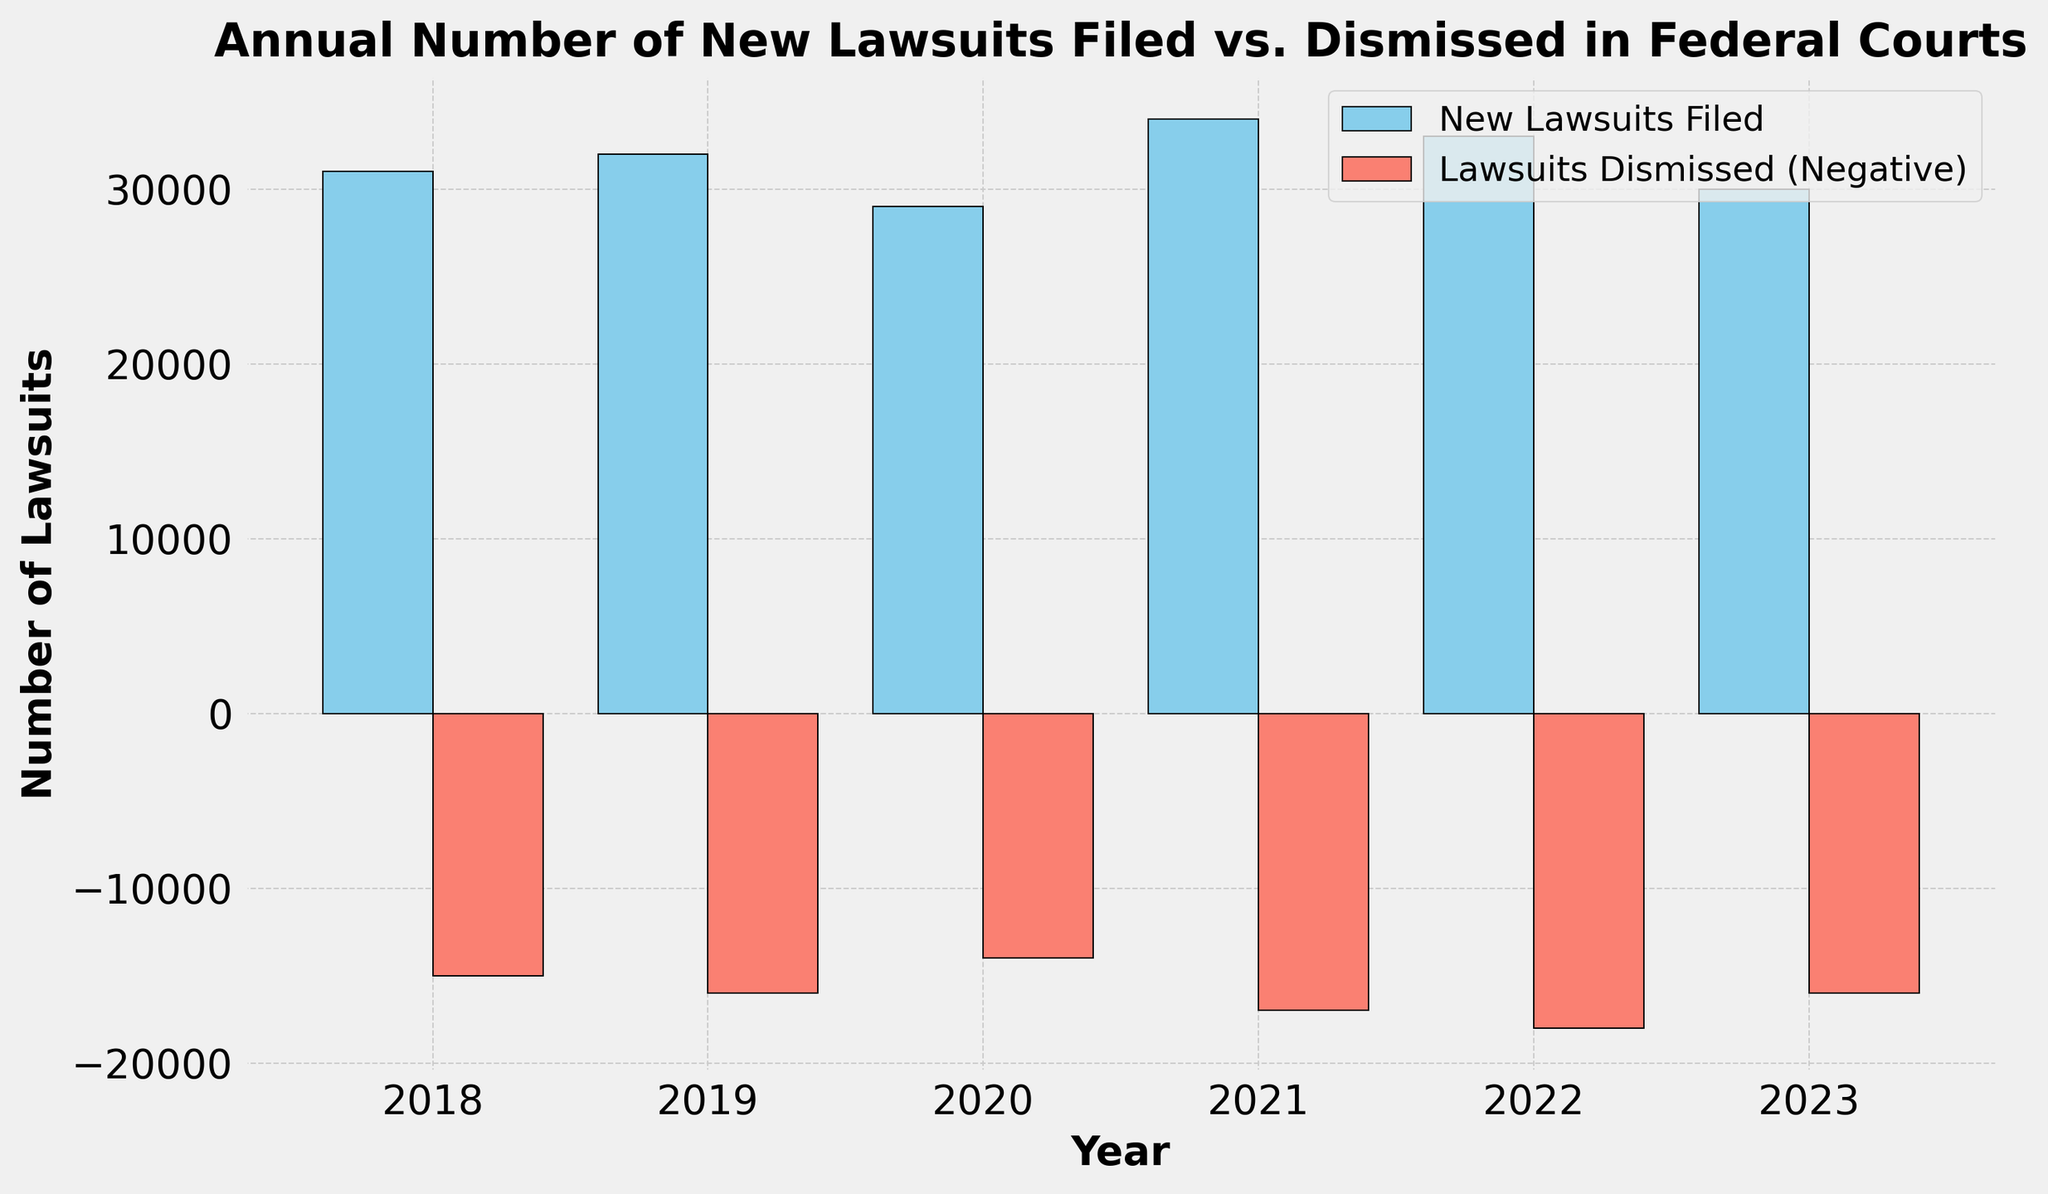What is the total number of new lawsuits filed in 2019 and 2020? To find the total number of new lawsuits filed in 2019 and 2020, add the number of new lawsuits in these years: 32,000 (2019) + 29,000 (2020) = 61,000
Answer: 61,000 How many more lawsuits were dismissed in 2022 compared to 2020? To find how many more lawsuits were dismissed in 2022 compared to 2020, subtract the number of lawsuits dismissed in 2020 from the number dismissed in 2022: 18,000 (2022) - 14,000 (2020) = 4,000
Answer: 4,000 What year had the highest number of new lawsuits filed? From the visual plot, the year with the tallest blue bar, representing new lawsuits filed, is 2021 with 34,000 lawsuits.
Answer: 2021 Compare the number of new lawsuits filed and lawsuits dismissed in 2018. Are more lawsuits filed or dismissed? In 2018, compare the height of the blue bar (new lawsuits) to the salmon bar (dismissed lawsuits). The new lawsuits filed are 31,000, while the dismissed lawsuits are 15,000, so more lawsuits were filed.
Answer: More lawsuits were filed What is the average number of new lawsuits filed from 2018 to 2023? To find the average, sum up the number of new lawsuits filed from 2018 to 2023 and divide by 6. (31,000 + 32,000 + 29,000 + 34,000 + 33,000 + 30,000) / 6 = 189,000 / 6 = 31,500
Answer: 31,500 In which year is the difference between new lawsuits filed and lawsuits dismissed the greatest? Calculate the difference for each year and compare them:
2018: 31,000 - 15,000 = 16,000
2019: 32,000 - 16,000 = 16,000
2020: 29,000 - 14,000 = 15,000
2021: 34,000 - 17,000 = 17,000
2022: 33,000 - 18,000 = 15,000
2023: 30,000 - 16,000 = 14,000
The greatest difference is in 2021 with 17,000.
Answer: 2021 